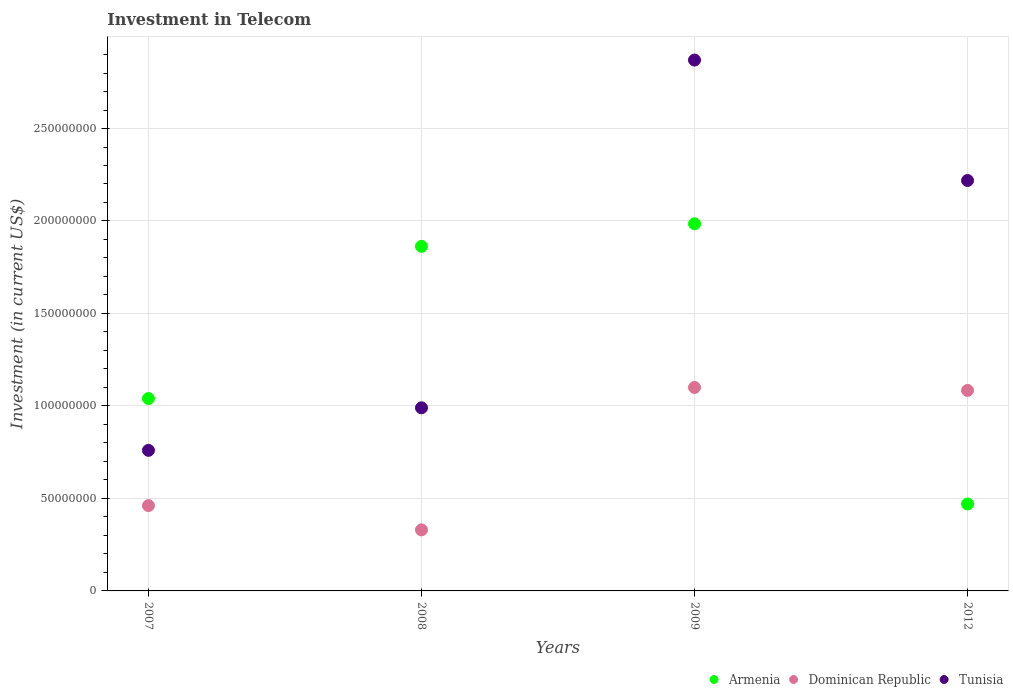Is the number of dotlines equal to the number of legend labels?
Offer a terse response. Yes. What is the amount invested in telecom in Tunisia in 2008?
Your response must be concise. 9.90e+07. Across all years, what is the maximum amount invested in telecom in Armenia?
Your answer should be compact. 1.98e+08. Across all years, what is the minimum amount invested in telecom in Tunisia?
Provide a succinct answer. 7.60e+07. What is the total amount invested in telecom in Armenia in the graph?
Your answer should be very brief. 5.36e+08. What is the difference between the amount invested in telecom in Armenia in 2007 and that in 2008?
Your answer should be compact. -8.23e+07. What is the difference between the amount invested in telecom in Armenia in 2008 and the amount invested in telecom in Dominican Republic in 2012?
Offer a very short reply. 7.79e+07. What is the average amount invested in telecom in Dominican Republic per year?
Your answer should be compact. 7.44e+07. In the year 2008, what is the difference between the amount invested in telecom in Tunisia and amount invested in telecom in Dominican Republic?
Give a very brief answer. 6.60e+07. Is the amount invested in telecom in Tunisia in 2008 less than that in 2009?
Give a very brief answer. Yes. Is the difference between the amount invested in telecom in Tunisia in 2009 and 2012 greater than the difference between the amount invested in telecom in Dominican Republic in 2009 and 2012?
Provide a succinct answer. Yes. What is the difference between the highest and the second highest amount invested in telecom in Dominican Republic?
Give a very brief answer. 1.60e+06. What is the difference between the highest and the lowest amount invested in telecom in Tunisia?
Your answer should be compact. 2.11e+08. Is the sum of the amount invested in telecom in Armenia in 2009 and 2012 greater than the maximum amount invested in telecom in Tunisia across all years?
Offer a very short reply. No. Is the amount invested in telecom in Tunisia strictly greater than the amount invested in telecom in Dominican Republic over the years?
Give a very brief answer. Yes. Is the amount invested in telecom in Armenia strictly less than the amount invested in telecom in Tunisia over the years?
Your answer should be very brief. No. How many dotlines are there?
Keep it short and to the point. 3. How many years are there in the graph?
Give a very brief answer. 4. What is the difference between two consecutive major ticks on the Y-axis?
Give a very brief answer. 5.00e+07. Does the graph contain any zero values?
Your answer should be compact. No. Where does the legend appear in the graph?
Offer a very short reply. Bottom right. How are the legend labels stacked?
Ensure brevity in your answer.  Horizontal. What is the title of the graph?
Ensure brevity in your answer.  Investment in Telecom. What is the label or title of the Y-axis?
Give a very brief answer. Investment (in current US$). What is the Investment (in current US$) in Armenia in 2007?
Provide a succinct answer. 1.04e+08. What is the Investment (in current US$) of Dominican Republic in 2007?
Your response must be concise. 4.61e+07. What is the Investment (in current US$) in Tunisia in 2007?
Keep it short and to the point. 7.60e+07. What is the Investment (in current US$) of Armenia in 2008?
Give a very brief answer. 1.86e+08. What is the Investment (in current US$) in Dominican Republic in 2008?
Keep it short and to the point. 3.30e+07. What is the Investment (in current US$) of Tunisia in 2008?
Ensure brevity in your answer.  9.90e+07. What is the Investment (in current US$) in Armenia in 2009?
Ensure brevity in your answer.  1.98e+08. What is the Investment (in current US$) of Dominican Republic in 2009?
Keep it short and to the point. 1.10e+08. What is the Investment (in current US$) in Tunisia in 2009?
Your answer should be very brief. 2.87e+08. What is the Investment (in current US$) of Armenia in 2012?
Offer a very short reply. 4.70e+07. What is the Investment (in current US$) in Dominican Republic in 2012?
Offer a terse response. 1.08e+08. What is the Investment (in current US$) in Tunisia in 2012?
Ensure brevity in your answer.  2.22e+08. Across all years, what is the maximum Investment (in current US$) in Armenia?
Your answer should be compact. 1.98e+08. Across all years, what is the maximum Investment (in current US$) of Dominican Republic?
Give a very brief answer. 1.10e+08. Across all years, what is the maximum Investment (in current US$) of Tunisia?
Offer a terse response. 2.87e+08. Across all years, what is the minimum Investment (in current US$) of Armenia?
Provide a succinct answer. 4.70e+07. Across all years, what is the minimum Investment (in current US$) of Dominican Republic?
Your answer should be very brief. 3.30e+07. Across all years, what is the minimum Investment (in current US$) in Tunisia?
Make the answer very short. 7.60e+07. What is the total Investment (in current US$) of Armenia in the graph?
Offer a terse response. 5.36e+08. What is the total Investment (in current US$) in Dominican Republic in the graph?
Provide a short and direct response. 2.98e+08. What is the total Investment (in current US$) of Tunisia in the graph?
Provide a short and direct response. 6.84e+08. What is the difference between the Investment (in current US$) of Armenia in 2007 and that in 2008?
Ensure brevity in your answer.  -8.23e+07. What is the difference between the Investment (in current US$) in Dominican Republic in 2007 and that in 2008?
Ensure brevity in your answer.  1.31e+07. What is the difference between the Investment (in current US$) in Tunisia in 2007 and that in 2008?
Keep it short and to the point. -2.30e+07. What is the difference between the Investment (in current US$) in Armenia in 2007 and that in 2009?
Provide a succinct answer. -9.45e+07. What is the difference between the Investment (in current US$) in Dominican Republic in 2007 and that in 2009?
Your answer should be very brief. -6.39e+07. What is the difference between the Investment (in current US$) of Tunisia in 2007 and that in 2009?
Your response must be concise. -2.11e+08. What is the difference between the Investment (in current US$) of Armenia in 2007 and that in 2012?
Offer a terse response. 5.70e+07. What is the difference between the Investment (in current US$) in Dominican Republic in 2007 and that in 2012?
Your answer should be compact. -6.23e+07. What is the difference between the Investment (in current US$) in Tunisia in 2007 and that in 2012?
Your response must be concise. -1.46e+08. What is the difference between the Investment (in current US$) in Armenia in 2008 and that in 2009?
Your response must be concise. -1.22e+07. What is the difference between the Investment (in current US$) in Dominican Republic in 2008 and that in 2009?
Your answer should be compact. -7.70e+07. What is the difference between the Investment (in current US$) of Tunisia in 2008 and that in 2009?
Your response must be concise. -1.88e+08. What is the difference between the Investment (in current US$) in Armenia in 2008 and that in 2012?
Provide a short and direct response. 1.39e+08. What is the difference between the Investment (in current US$) of Dominican Republic in 2008 and that in 2012?
Your answer should be very brief. -7.54e+07. What is the difference between the Investment (in current US$) in Tunisia in 2008 and that in 2012?
Provide a succinct answer. -1.23e+08. What is the difference between the Investment (in current US$) in Armenia in 2009 and that in 2012?
Your response must be concise. 1.52e+08. What is the difference between the Investment (in current US$) in Dominican Republic in 2009 and that in 2012?
Ensure brevity in your answer.  1.60e+06. What is the difference between the Investment (in current US$) of Tunisia in 2009 and that in 2012?
Ensure brevity in your answer.  6.51e+07. What is the difference between the Investment (in current US$) of Armenia in 2007 and the Investment (in current US$) of Dominican Republic in 2008?
Give a very brief answer. 7.10e+07. What is the difference between the Investment (in current US$) in Armenia in 2007 and the Investment (in current US$) in Tunisia in 2008?
Offer a terse response. 5.00e+06. What is the difference between the Investment (in current US$) in Dominican Republic in 2007 and the Investment (in current US$) in Tunisia in 2008?
Your answer should be very brief. -5.29e+07. What is the difference between the Investment (in current US$) in Armenia in 2007 and the Investment (in current US$) in Dominican Republic in 2009?
Give a very brief answer. -6.00e+06. What is the difference between the Investment (in current US$) of Armenia in 2007 and the Investment (in current US$) of Tunisia in 2009?
Provide a short and direct response. -1.83e+08. What is the difference between the Investment (in current US$) in Dominican Republic in 2007 and the Investment (in current US$) in Tunisia in 2009?
Keep it short and to the point. -2.41e+08. What is the difference between the Investment (in current US$) in Armenia in 2007 and the Investment (in current US$) in Dominican Republic in 2012?
Provide a succinct answer. -4.40e+06. What is the difference between the Investment (in current US$) in Armenia in 2007 and the Investment (in current US$) in Tunisia in 2012?
Keep it short and to the point. -1.18e+08. What is the difference between the Investment (in current US$) in Dominican Republic in 2007 and the Investment (in current US$) in Tunisia in 2012?
Give a very brief answer. -1.76e+08. What is the difference between the Investment (in current US$) in Armenia in 2008 and the Investment (in current US$) in Dominican Republic in 2009?
Your response must be concise. 7.63e+07. What is the difference between the Investment (in current US$) of Armenia in 2008 and the Investment (in current US$) of Tunisia in 2009?
Give a very brief answer. -1.01e+08. What is the difference between the Investment (in current US$) in Dominican Republic in 2008 and the Investment (in current US$) in Tunisia in 2009?
Give a very brief answer. -2.54e+08. What is the difference between the Investment (in current US$) of Armenia in 2008 and the Investment (in current US$) of Dominican Republic in 2012?
Your answer should be compact. 7.79e+07. What is the difference between the Investment (in current US$) in Armenia in 2008 and the Investment (in current US$) in Tunisia in 2012?
Ensure brevity in your answer.  -3.56e+07. What is the difference between the Investment (in current US$) of Dominican Republic in 2008 and the Investment (in current US$) of Tunisia in 2012?
Offer a very short reply. -1.89e+08. What is the difference between the Investment (in current US$) in Armenia in 2009 and the Investment (in current US$) in Dominican Republic in 2012?
Give a very brief answer. 9.01e+07. What is the difference between the Investment (in current US$) of Armenia in 2009 and the Investment (in current US$) of Tunisia in 2012?
Provide a succinct answer. -2.34e+07. What is the difference between the Investment (in current US$) of Dominican Republic in 2009 and the Investment (in current US$) of Tunisia in 2012?
Your answer should be very brief. -1.12e+08. What is the average Investment (in current US$) in Armenia per year?
Your answer should be compact. 1.34e+08. What is the average Investment (in current US$) of Dominican Republic per year?
Your answer should be compact. 7.44e+07. What is the average Investment (in current US$) of Tunisia per year?
Provide a succinct answer. 1.71e+08. In the year 2007, what is the difference between the Investment (in current US$) of Armenia and Investment (in current US$) of Dominican Republic?
Ensure brevity in your answer.  5.79e+07. In the year 2007, what is the difference between the Investment (in current US$) in Armenia and Investment (in current US$) in Tunisia?
Your answer should be compact. 2.80e+07. In the year 2007, what is the difference between the Investment (in current US$) in Dominican Republic and Investment (in current US$) in Tunisia?
Your answer should be compact. -2.99e+07. In the year 2008, what is the difference between the Investment (in current US$) of Armenia and Investment (in current US$) of Dominican Republic?
Make the answer very short. 1.53e+08. In the year 2008, what is the difference between the Investment (in current US$) of Armenia and Investment (in current US$) of Tunisia?
Offer a terse response. 8.73e+07. In the year 2008, what is the difference between the Investment (in current US$) of Dominican Republic and Investment (in current US$) of Tunisia?
Keep it short and to the point. -6.60e+07. In the year 2009, what is the difference between the Investment (in current US$) of Armenia and Investment (in current US$) of Dominican Republic?
Offer a very short reply. 8.85e+07. In the year 2009, what is the difference between the Investment (in current US$) of Armenia and Investment (in current US$) of Tunisia?
Offer a terse response. -8.85e+07. In the year 2009, what is the difference between the Investment (in current US$) of Dominican Republic and Investment (in current US$) of Tunisia?
Ensure brevity in your answer.  -1.77e+08. In the year 2012, what is the difference between the Investment (in current US$) of Armenia and Investment (in current US$) of Dominican Republic?
Offer a very short reply. -6.14e+07. In the year 2012, what is the difference between the Investment (in current US$) of Armenia and Investment (in current US$) of Tunisia?
Offer a terse response. -1.75e+08. In the year 2012, what is the difference between the Investment (in current US$) in Dominican Republic and Investment (in current US$) in Tunisia?
Give a very brief answer. -1.14e+08. What is the ratio of the Investment (in current US$) in Armenia in 2007 to that in 2008?
Offer a terse response. 0.56. What is the ratio of the Investment (in current US$) of Dominican Republic in 2007 to that in 2008?
Give a very brief answer. 1.4. What is the ratio of the Investment (in current US$) in Tunisia in 2007 to that in 2008?
Provide a short and direct response. 0.77. What is the ratio of the Investment (in current US$) of Armenia in 2007 to that in 2009?
Your response must be concise. 0.52. What is the ratio of the Investment (in current US$) in Dominican Republic in 2007 to that in 2009?
Ensure brevity in your answer.  0.42. What is the ratio of the Investment (in current US$) in Tunisia in 2007 to that in 2009?
Your answer should be very brief. 0.26. What is the ratio of the Investment (in current US$) in Armenia in 2007 to that in 2012?
Provide a short and direct response. 2.21. What is the ratio of the Investment (in current US$) in Dominican Republic in 2007 to that in 2012?
Offer a terse response. 0.43. What is the ratio of the Investment (in current US$) in Tunisia in 2007 to that in 2012?
Your response must be concise. 0.34. What is the ratio of the Investment (in current US$) of Armenia in 2008 to that in 2009?
Give a very brief answer. 0.94. What is the ratio of the Investment (in current US$) of Dominican Republic in 2008 to that in 2009?
Make the answer very short. 0.3. What is the ratio of the Investment (in current US$) in Tunisia in 2008 to that in 2009?
Make the answer very short. 0.34. What is the ratio of the Investment (in current US$) in Armenia in 2008 to that in 2012?
Your answer should be compact. 3.96. What is the ratio of the Investment (in current US$) in Dominican Republic in 2008 to that in 2012?
Keep it short and to the point. 0.3. What is the ratio of the Investment (in current US$) in Tunisia in 2008 to that in 2012?
Your answer should be compact. 0.45. What is the ratio of the Investment (in current US$) in Armenia in 2009 to that in 2012?
Your answer should be very brief. 4.22. What is the ratio of the Investment (in current US$) of Dominican Republic in 2009 to that in 2012?
Provide a succinct answer. 1.01. What is the ratio of the Investment (in current US$) in Tunisia in 2009 to that in 2012?
Provide a succinct answer. 1.29. What is the difference between the highest and the second highest Investment (in current US$) of Armenia?
Keep it short and to the point. 1.22e+07. What is the difference between the highest and the second highest Investment (in current US$) of Dominican Republic?
Offer a very short reply. 1.60e+06. What is the difference between the highest and the second highest Investment (in current US$) of Tunisia?
Give a very brief answer. 6.51e+07. What is the difference between the highest and the lowest Investment (in current US$) of Armenia?
Keep it short and to the point. 1.52e+08. What is the difference between the highest and the lowest Investment (in current US$) of Dominican Republic?
Give a very brief answer. 7.70e+07. What is the difference between the highest and the lowest Investment (in current US$) of Tunisia?
Your response must be concise. 2.11e+08. 